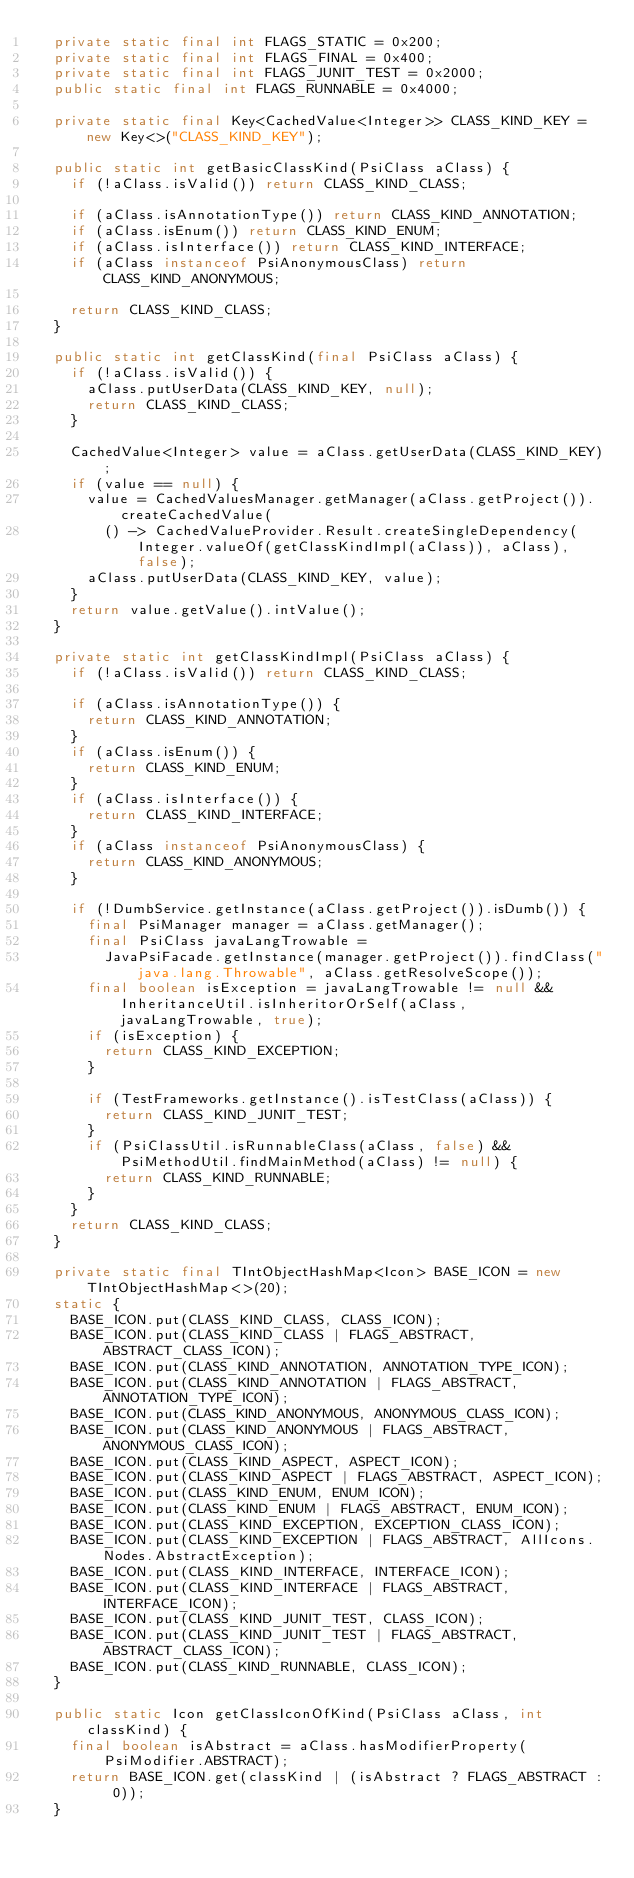Convert code to text. <code><loc_0><loc_0><loc_500><loc_500><_Java_>  private static final int FLAGS_STATIC = 0x200;
  private static final int FLAGS_FINAL = 0x400;
  private static final int FLAGS_JUNIT_TEST = 0x2000;
  public static final int FLAGS_RUNNABLE = 0x4000;

  private static final Key<CachedValue<Integer>> CLASS_KIND_KEY = new Key<>("CLASS_KIND_KEY");

  public static int getBasicClassKind(PsiClass aClass) {
    if (!aClass.isValid()) return CLASS_KIND_CLASS;

    if (aClass.isAnnotationType()) return CLASS_KIND_ANNOTATION;
    if (aClass.isEnum()) return CLASS_KIND_ENUM;
    if (aClass.isInterface()) return CLASS_KIND_INTERFACE;
    if (aClass instanceof PsiAnonymousClass) return CLASS_KIND_ANONYMOUS;

    return CLASS_KIND_CLASS;
  }

  public static int getClassKind(final PsiClass aClass) {
    if (!aClass.isValid()) {
      aClass.putUserData(CLASS_KIND_KEY, null);
      return CLASS_KIND_CLASS;
    }

    CachedValue<Integer> value = aClass.getUserData(CLASS_KIND_KEY);
    if (value == null) {
      value = CachedValuesManager.getManager(aClass.getProject()).createCachedValue(
        () -> CachedValueProvider.Result.createSingleDependency(Integer.valueOf(getClassKindImpl(aClass)), aClass), false);
      aClass.putUserData(CLASS_KIND_KEY, value);
    }
    return value.getValue().intValue();
  }

  private static int getClassKindImpl(PsiClass aClass) {
    if (!aClass.isValid()) return CLASS_KIND_CLASS;

    if (aClass.isAnnotationType()) {
      return CLASS_KIND_ANNOTATION;
    }
    if (aClass.isEnum()) {
      return CLASS_KIND_ENUM;
    }
    if (aClass.isInterface()) {
      return CLASS_KIND_INTERFACE;
    }
    if (aClass instanceof PsiAnonymousClass) {
      return CLASS_KIND_ANONYMOUS;
    }

    if (!DumbService.getInstance(aClass.getProject()).isDumb()) {
      final PsiManager manager = aClass.getManager();
      final PsiClass javaLangTrowable =
        JavaPsiFacade.getInstance(manager.getProject()).findClass("java.lang.Throwable", aClass.getResolveScope());
      final boolean isException = javaLangTrowable != null && InheritanceUtil.isInheritorOrSelf(aClass, javaLangTrowable, true);
      if (isException) {
        return CLASS_KIND_EXCEPTION;
      }

      if (TestFrameworks.getInstance().isTestClass(aClass)) {
        return CLASS_KIND_JUNIT_TEST;
      }
      if (PsiClassUtil.isRunnableClass(aClass, false) && PsiMethodUtil.findMainMethod(aClass) != null) {
        return CLASS_KIND_RUNNABLE;
      }
    }
    return CLASS_KIND_CLASS;
  }

  private static final TIntObjectHashMap<Icon> BASE_ICON = new TIntObjectHashMap<>(20);
  static {
    BASE_ICON.put(CLASS_KIND_CLASS, CLASS_ICON);
    BASE_ICON.put(CLASS_KIND_CLASS | FLAGS_ABSTRACT, ABSTRACT_CLASS_ICON);
    BASE_ICON.put(CLASS_KIND_ANNOTATION, ANNOTATION_TYPE_ICON);
    BASE_ICON.put(CLASS_KIND_ANNOTATION | FLAGS_ABSTRACT, ANNOTATION_TYPE_ICON);
    BASE_ICON.put(CLASS_KIND_ANONYMOUS, ANONYMOUS_CLASS_ICON);
    BASE_ICON.put(CLASS_KIND_ANONYMOUS | FLAGS_ABSTRACT, ANONYMOUS_CLASS_ICON);
    BASE_ICON.put(CLASS_KIND_ASPECT, ASPECT_ICON);
    BASE_ICON.put(CLASS_KIND_ASPECT | FLAGS_ABSTRACT, ASPECT_ICON);
    BASE_ICON.put(CLASS_KIND_ENUM, ENUM_ICON);
    BASE_ICON.put(CLASS_KIND_ENUM | FLAGS_ABSTRACT, ENUM_ICON);
    BASE_ICON.put(CLASS_KIND_EXCEPTION, EXCEPTION_CLASS_ICON);
    BASE_ICON.put(CLASS_KIND_EXCEPTION | FLAGS_ABSTRACT, AllIcons.Nodes.AbstractException);
    BASE_ICON.put(CLASS_KIND_INTERFACE, INTERFACE_ICON);
    BASE_ICON.put(CLASS_KIND_INTERFACE | FLAGS_ABSTRACT, INTERFACE_ICON);
    BASE_ICON.put(CLASS_KIND_JUNIT_TEST, CLASS_ICON);
    BASE_ICON.put(CLASS_KIND_JUNIT_TEST | FLAGS_ABSTRACT, ABSTRACT_CLASS_ICON);
    BASE_ICON.put(CLASS_KIND_RUNNABLE, CLASS_ICON);
  }

  public static Icon getClassIconOfKind(PsiClass aClass, int classKind) {
    final boolean isAbstract = aClass.hasModifierProperty(PsiModifier.ABSTRACT);
    return BASE_ICON.get(classKind | (isAbstract ? FLAGS_ABSTRACT : 0));
  }
</code> 